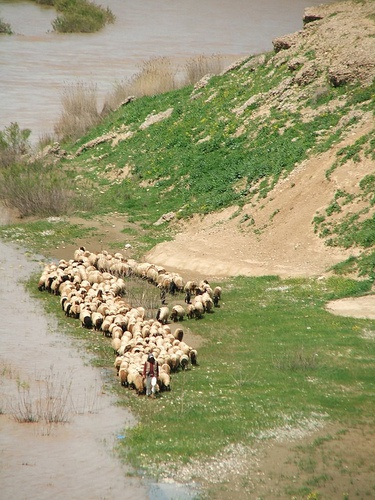Describe the objects in this image and their specific colors. I can see sheep in olive, tan, and beige tones, people in olive, gray, and maroon tones, sheep in olive, black, tan, and beige tones, sheep in olive, black, tan, and beige tones, and sheep in olive, black, beige, tan, and maroon tones in this image. 